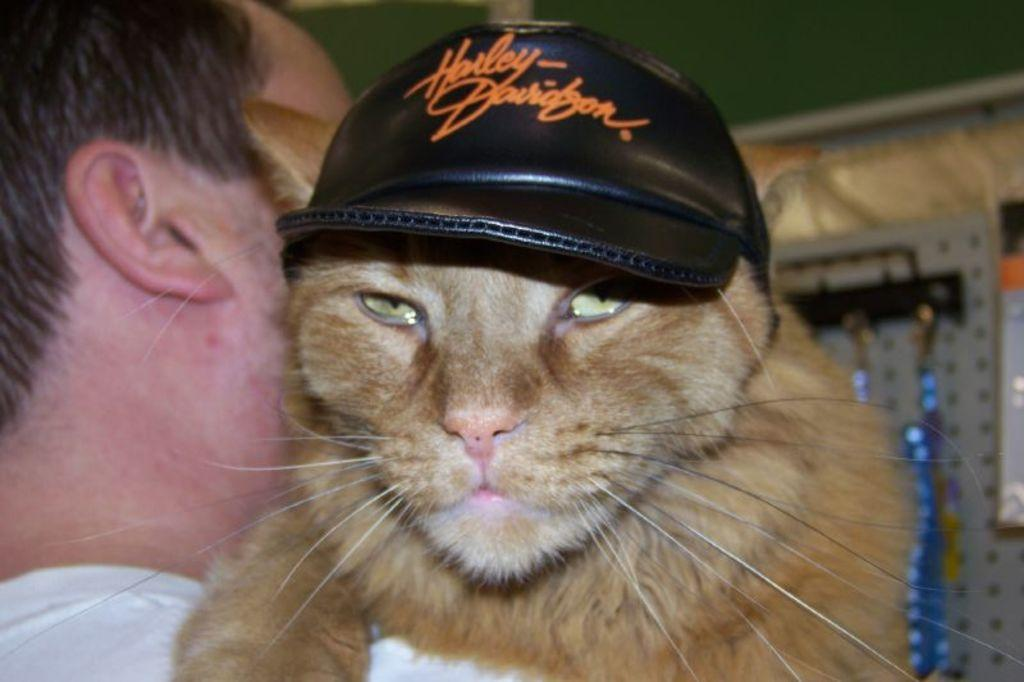Who is present in the image? There is a man in the image. What other living creature is in the image? There is a cat in the image. What is the man doing with the cat? The man is holding the cat. How is the cat dressed? The cat is wearing a cap. What is the man wearing? The man is wearing a white t-shirt. What word is the man saying to the worm in the image? There is no worm present in the image, and the man is not saying any words. 